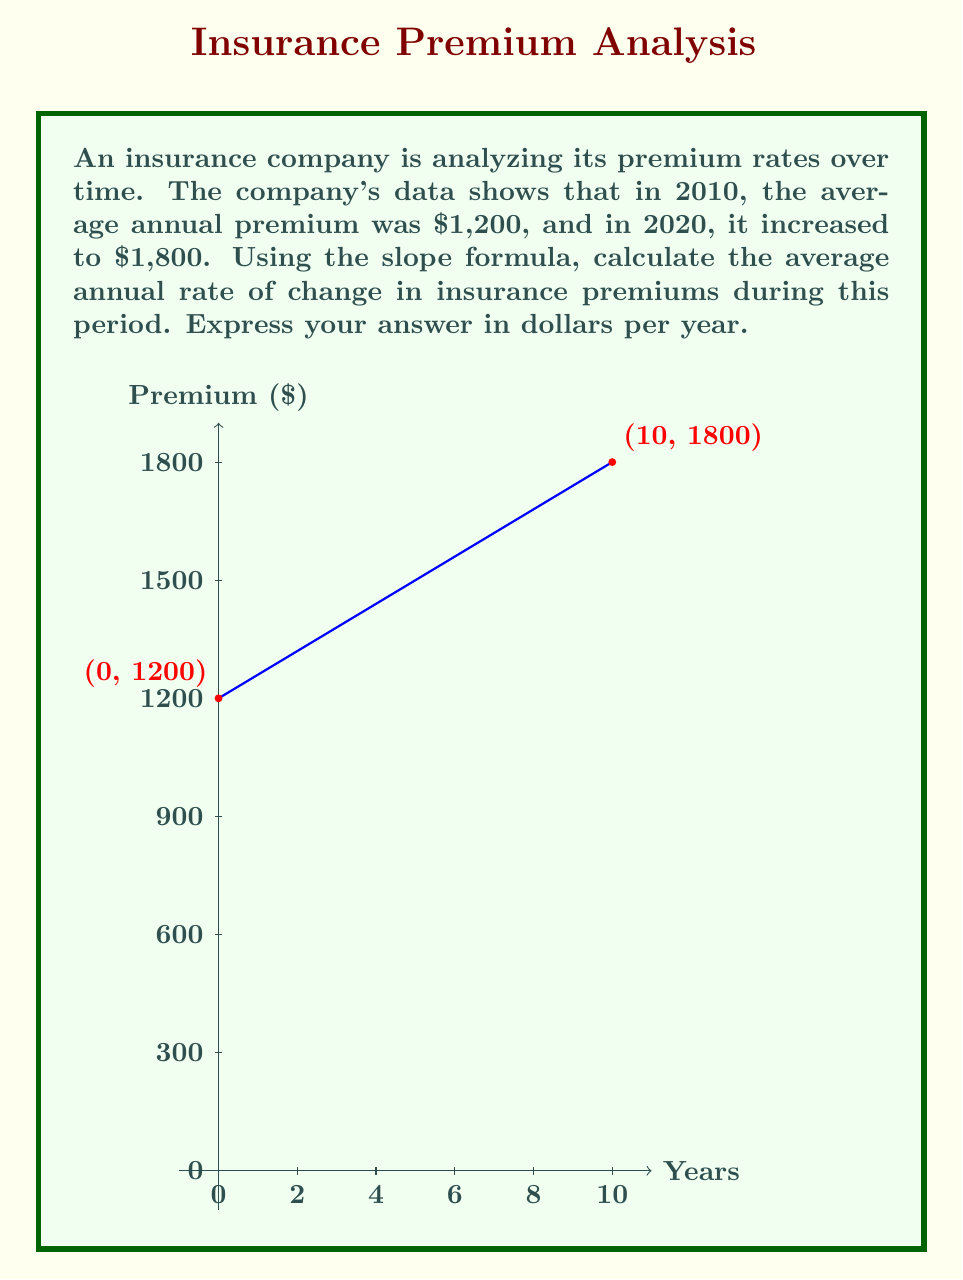Provide a solution to this math problem. To calculate the average annual rate of change in insurance premiums, we'll use the slope formula:

$$ m = \frac{y_2 - y_1}{x_2 - x_1} $$

Where:
- $m$ is the slope (rate of change)
- $(x_1, y_1)$ is the first point (2010, $1,200)
- $(x_2, y_2)$ is the second point (2020, $1,800)

Let's assign our values:
- $x_1 = 0$ (representing 2010)
- $y_1 = 1200$
- $x_2 = 10$ (representing 2020, 10 years later)
- $y_2 = 1800$

Now, let's substitute these values into the slope formula:

$$ m = \frac{1800 - 1200}{10 - 0} $$

$$ m = \frac{600}{10} $$

$$ m = 60 $$

This means the average rate of change is $60 per year.
Answer: $60 per year 